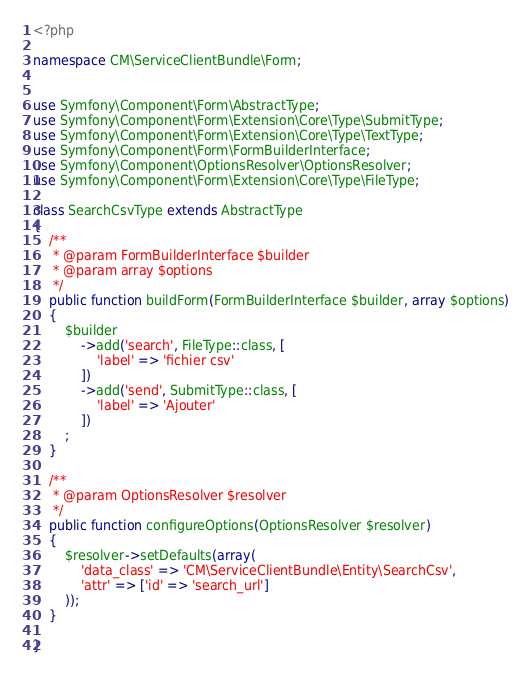<code> <loc_0><loc_0><loc_500><loc_500><_PHP_><?php

namespace CM\ServiceClientBundle\Form;


use Symfony\Component\Form\AbstractType;
use Symfony\Component\Form\Extension\Core\Type\SubmitType;
use Symfony\Component\Form\Extension\Core\Type\TextType;
use Symfony\Component\Form\FormBuilderInterface;
use Symfony\Component\OptionsResolver\OptionsResolver;
use Symfony\Component\Form\Extension\Core\Type\FileType;

class SearchCsvType extends AbstractType
{
    /**
     * @param FormBuilderInterface $builder
     * @param array $options
     */
    public function buildForm(FormBuilderInterface $builder, array $options)
    {
        $builder
            ->add('search', FileType::class, [
                'label' => 'fichier csv'
            ])
            ->add('send', SubmitType::class, [
                'label' => 'Ajouter'
            ])
        ;
    }

    /**
     * @param OptionsResolver $resolver
     */
    public function configureOptions(OptionsResolver $resolver)
    {
        $resolver->setDefaults(array(
            'data_class' => 'CM\ServiceClientBundle\Entity\SearchCsv',
            'attr' => ['id' => 'search_url']
        ));
    }

}</code> 